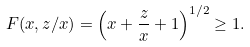Convert formula to latex. <formula><loc_0><loc_0><loc_500><loc_500>F ( x , z / x ) = \left ( x + \frac { z } { x } + 1 \right ) ^ { 1 / 2 } \geq 1 .</formula> 